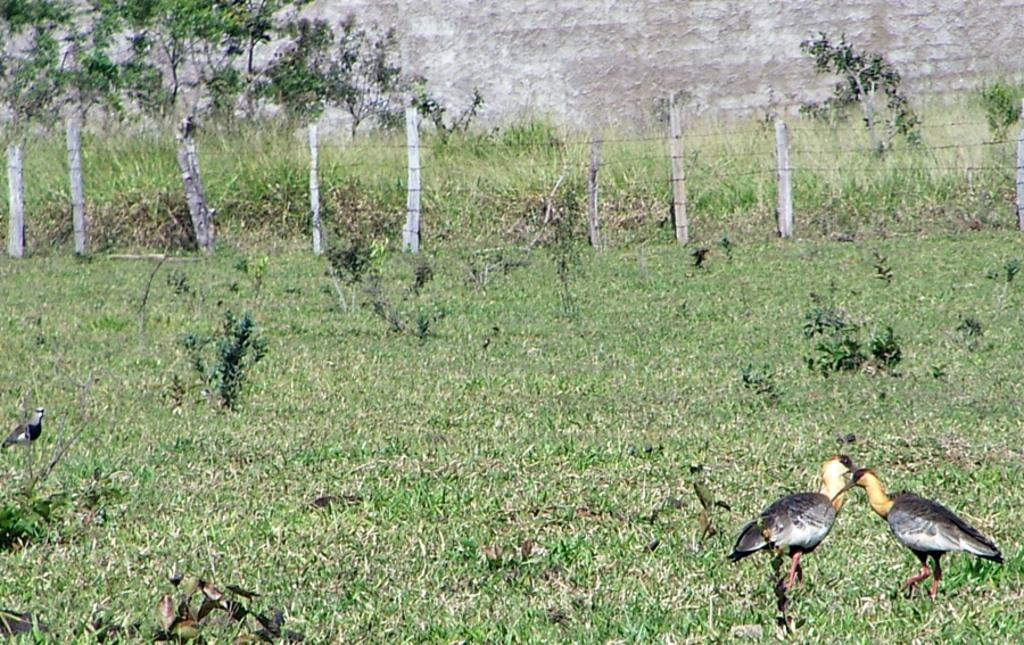Where was the picture taken? The picture was clicked outside. What can be seen in the right corner of the image? There are two birds in the right corner of the image. What type of vegetation is present in the image? There is green grass and plants in the image. What type of structures can be seen in the image? There are poles and a wall in the image. Can you describe any other objects in the image? There are other unspecified objects in the image. What type of vase is present in the image? There is no vase present in the image. Can you tell me how many noses are visible in the image? There are no noses visible in the image. 